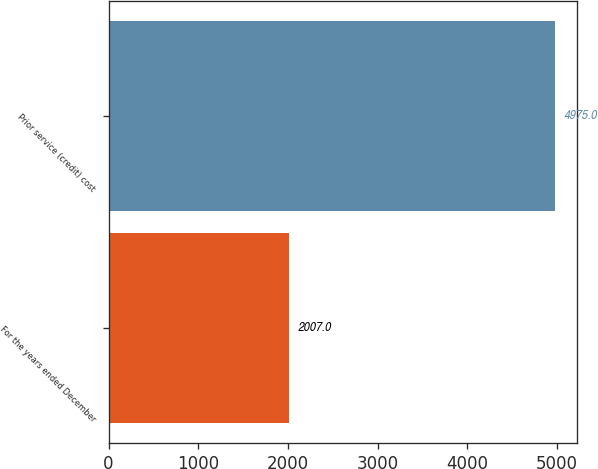Convert chart. <chart><loc_0><loc_0><loc_500><loc_500><bar_chart><fcel>For the years ended December<fcel>Prior service (credit) cost<nl><fcel>2007<fcel>4975<nl></chart> 